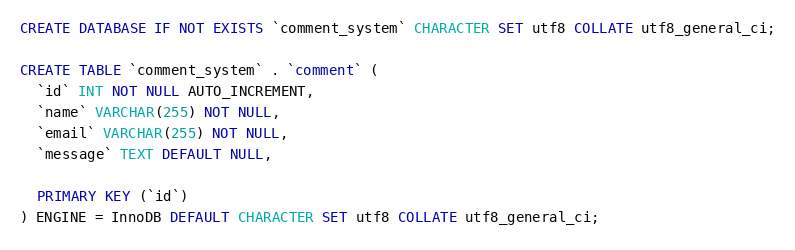Convert code to text. <code><loc_0><loc_0><loc_500><loc_500><_SQL_>CREATE DATABASE IF NOT EXISTS `comment_system` CHARACTER SET utf8 COLLATE utf8_general_ci;

CREATE TABLE `comment_system` . `comment` (
  `id` INT NOT NULL AUTO_INCREMENT,
  `name` VARCHAR(255) NOT NULL,
  `email` VARCHAR(255) NOT NULL,
  `message` TEXT DEFAULT NULL,

  PRIMARY KEY (`id`)
) ENGINE = InnoDB DEFAULT CHARACTER SET utf8 COLLATE utf8_general_ci;</code> 